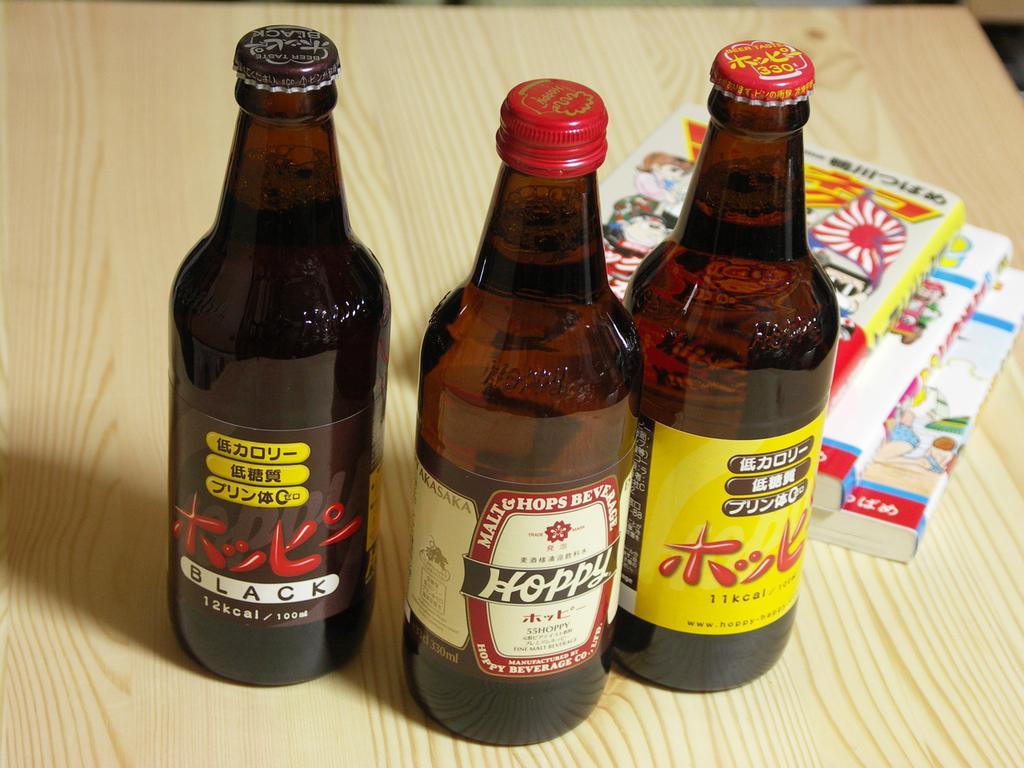Describe this image in one or two sentences. In this picture there is a table, with three wine bottles kept on it with three books. 